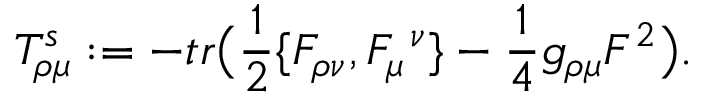Convert formula to latex. <formula><loc_0><loc_0><loc_500><loc_500>T _ { \rho \mu } ^ { s } \colon = - t r \left ( { \frac { 1 } { 2 } } \{ F _ { \rho \nu } , F _ { \mu } ^ { \ \nu } \} - { \frac { 1 } { 4 } } g _ { \rho \mu } F ^ { 2 } \right ) .</formula> 